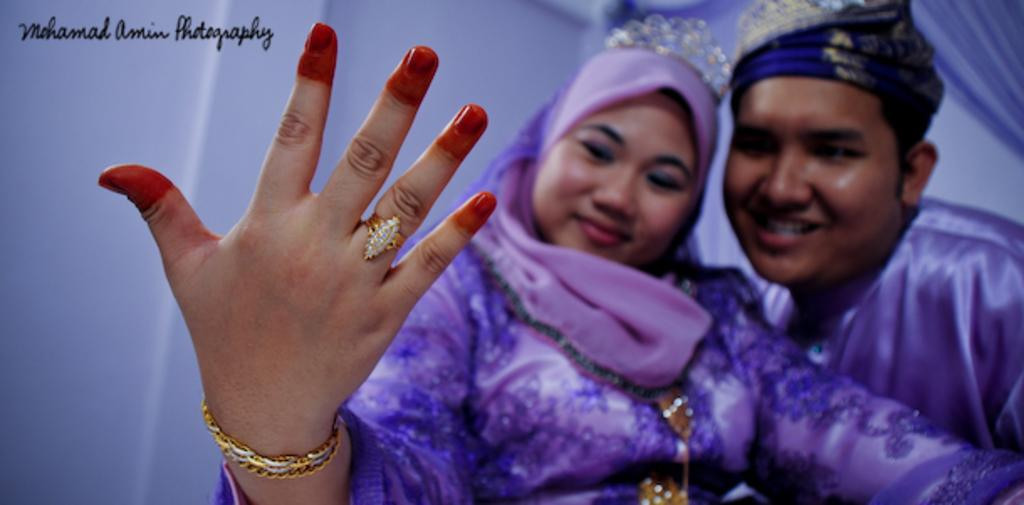Who are the people in the image? There is a man and a woman in the image. What are the facial expressions of the people in the image? Both the man and the woman are smiling in the image. What is the color of the background in the image? The background of the image is white. What is written at the top of the image? There is text written at the top of the image. How many ladybugs can be seen crawling on the man's knee in the image? There are no ladybugs present in the image, and the man's knee is not visible. 